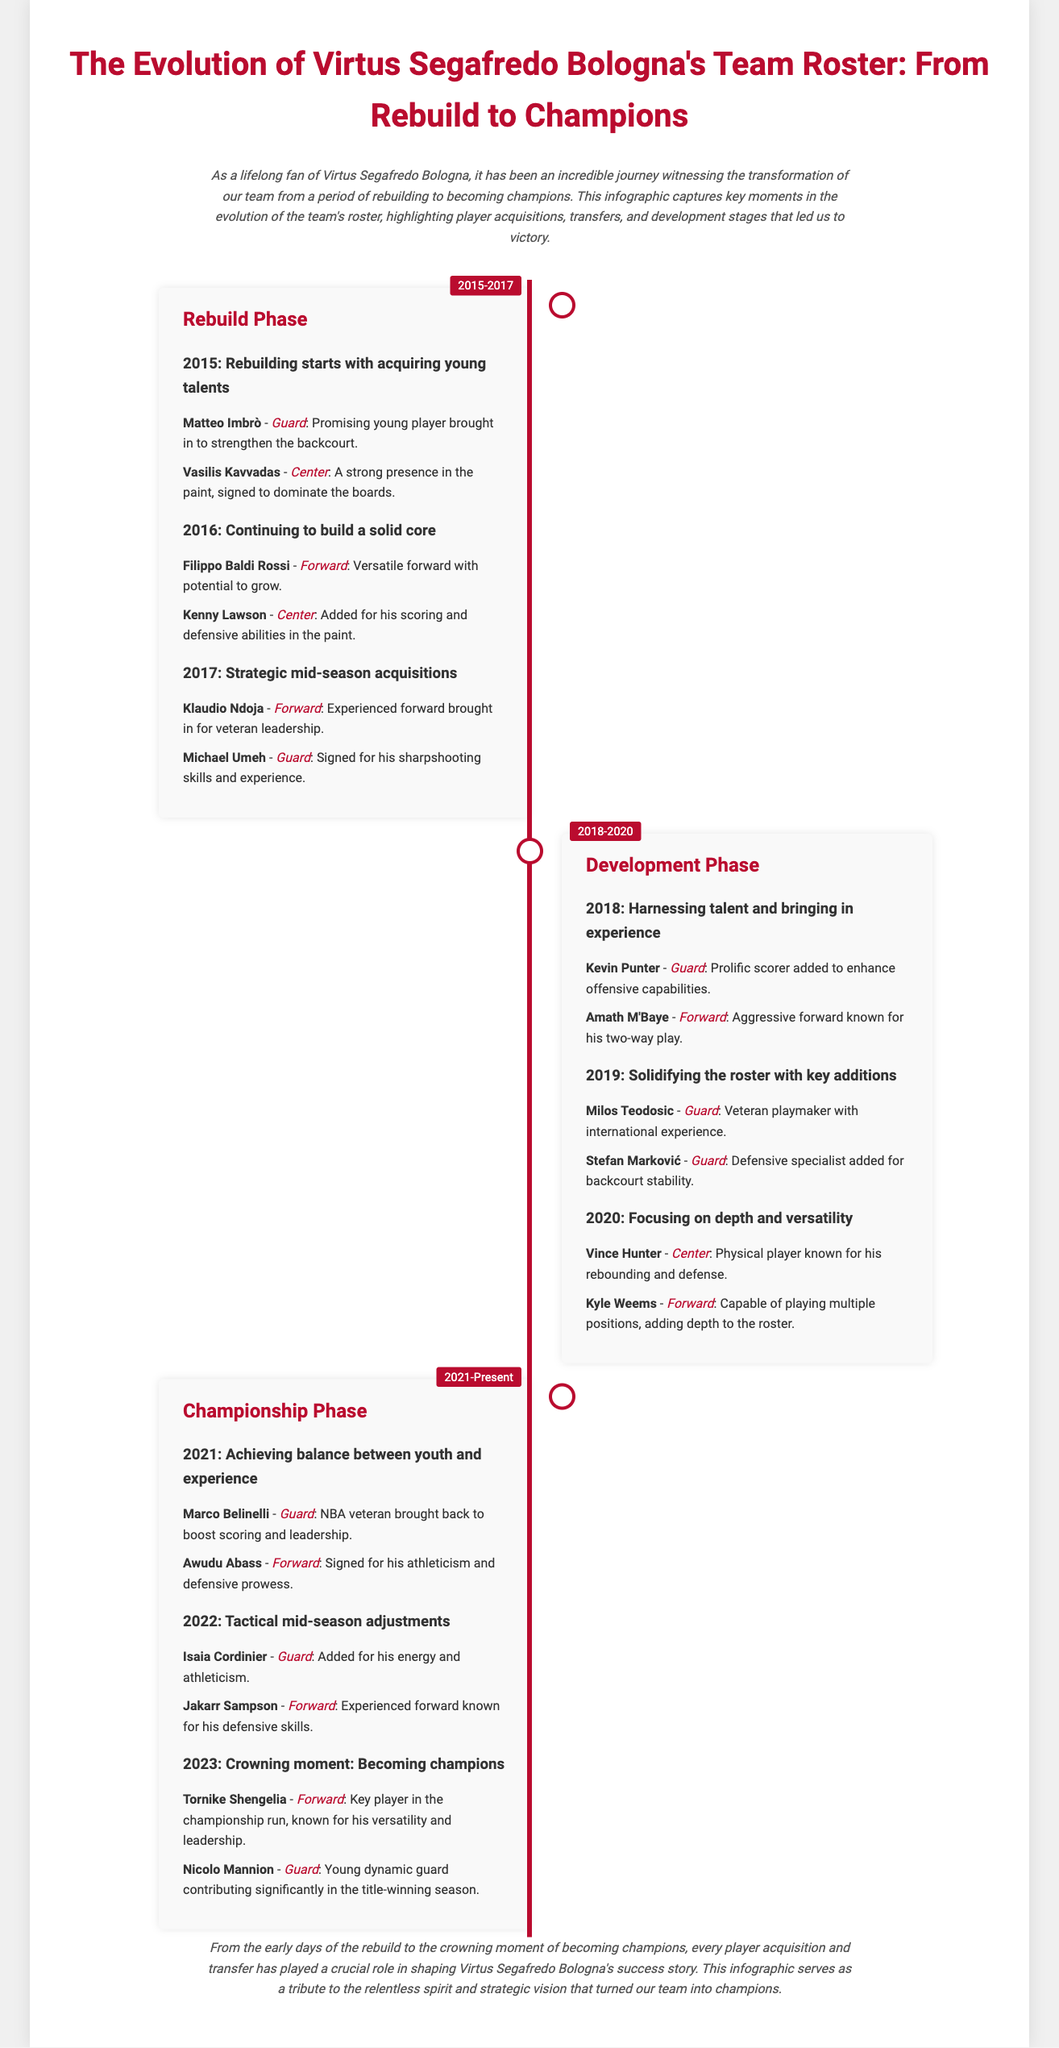what years mark the Rebuild Phase? The document specifically states that the Rebuild Phase spans from 2015 to 2017.
Answer: 2015-2017 who was signed as a prolific scorer in 2018? Kevin Punter is identified in the infographic as a prolific scorer added in 2018 to enhance offensive capabilities.
Answer: Kevin Punter which player was a key part of the championship run in 2023? Tornike Shengelia is highlighted as a key player known for his versatility and leadership during the championship run in 2023.
Answer: Tornike Shengelia how many players were mentioned during the Development Phase? The Development Phase lists a total of six players added between 2018 and 2020, with two players for each of the three years.
Answer: 6 what was the main focus during the 2020 phase? The focus in 2020 was on depth and versatility, as indicated in the h3 heading for that year.
Answer: Depth and versatility who was brought back in 2021 to boost scoring? Marco Belinelli, an NBA veteran, was brought back in 2021 as stated in the document.
Answer: Marco Belinelli what is the color associated with the timeline? The color that represents the timeline in the infographic is red, specifically referenced by the hexadecimal code provided in the style.
Answer: Red which phase includes strategic mid-season acquisitions? The Rebuild Phase includes strategic mid-season acquisitions in 2017 according to the timeline.
Answer: Rebuild Phase how does the infographic visually represent each phase? Each phase in the infographic is represented by distinct sections alternating on the left and right, along with a timeline running through the center.
Answer: Alternating sections 